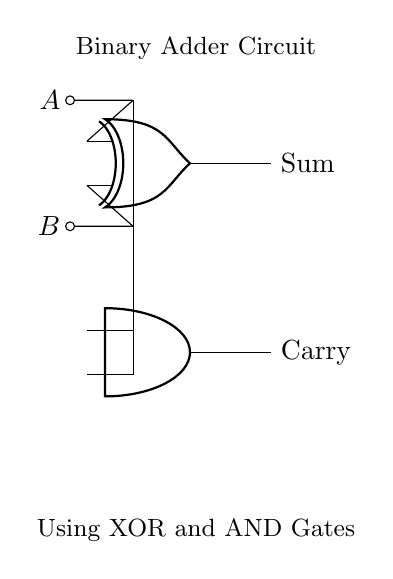What are the main components in this circuit? The main components in this circuit are the XOR gate and the AND gate, which are used to perform addition and derive the carry bit, respectively.
Answer: XOR gate and AND gate What is the purpose of the XOR gate in this circuit? The XOR gate calculates the sum output for the binary adder by performing an exclusive OR operation on the two input bits A and B. It outputs a high signal when the inputs are different.
Answer: Calculate sum What is the output name of the AND gate? The output name of the AND gate is "Carry", which represents the additional one-bit that is carried forward when both input bits A and B are high.
Answer: Carry What will the sum output be if inputs A and B are both 1? If both inputs A and B are 1, the XOR gate outputs 0 because it only outputs high when exactly one input is high, while the AND gate outputs 1 (indicating a carry).
Answer: 0 What do the inputs A and B represent in the context of this circuit? Inputs A and B represent the binary digits being added together in the binary addition operation. They can be either 0 or 1.
Answer: Binary digits How does the carry output validate the necessity of the AND gate? The carry output is essential for binary addition as it indicates when two bits added together exceed the binary value of 1 (i.e., when both are high), thus requiring the use of an additional bit. The AND gate produces this carry output.
Answer: Indicates necessity What happens if one input is 0 and the other is 1? If one input is 0 and the other is 1, the XOR gate outputs 1 (since only one input is high), and the AND gate outputs 0 (since both inputs must be 1 to produce a carry).
Answer: Sum is 1, Carry is 0 